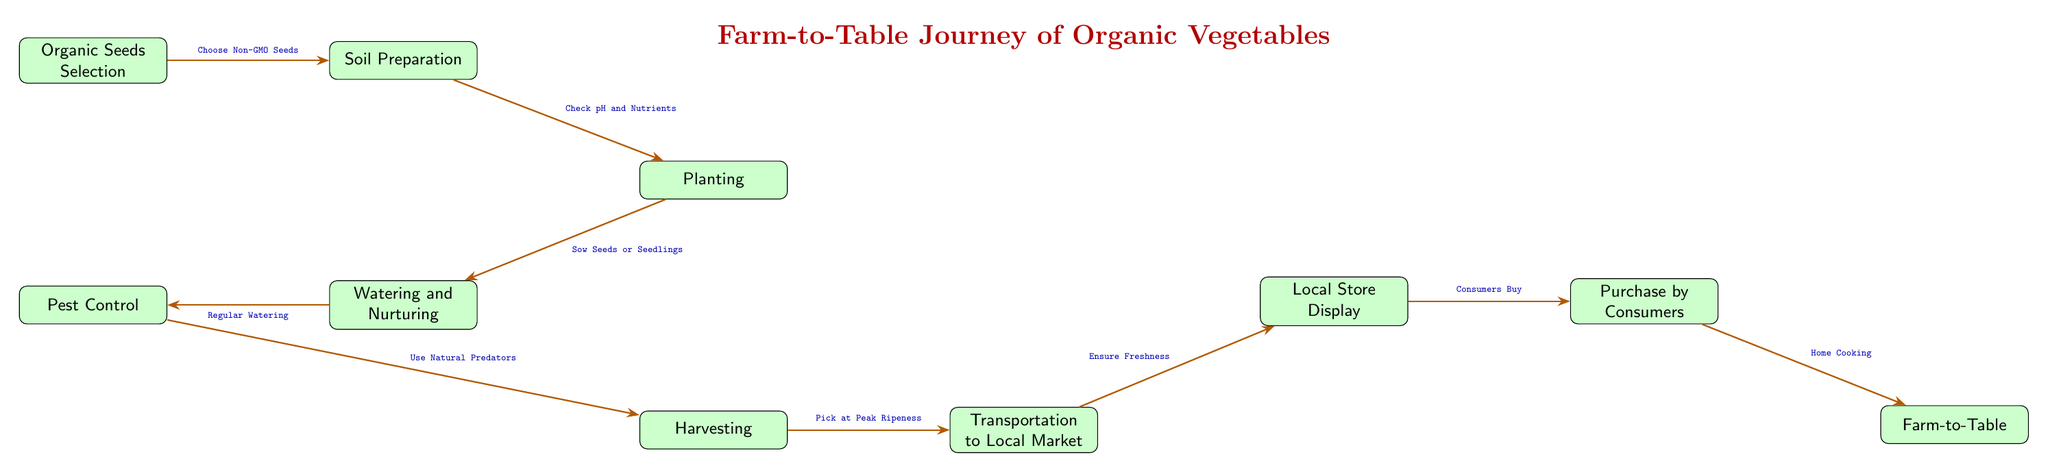What is the first step in the diagram? The first step in the diagram is located at the top, labeled "Organic Seeds Selection". It is the initial action taken in the farm-to-table journey.
Answer: Organic Seeds Selection How many main steps are there in the process? By counting the individual boxes, there are a total of 10 main steps outlined in the diagram, from "Organic Seeds Selection" to "Farm-to-Table".
Answer: 10 What is done immediately after Soil Preparation? The step that follows "Soil Preparation" is "Planting", which is indicated by the arrow connecting the two boxes in the diagram.
Answer: Planting Which step involves dealing with pests? The diagram indicates that "Pest Control" is the step related to managing pests, and it is connected to "Watering and Nurturing" before the harvesting phase.
Answer: Pest Control What is the action taken before harvesting? According to the diagram, the action taken before harvesting is "Watering and Nurturing". It emphasizes the care provided to the plants before they are harvested.
Answer: Watering and Nurturing Explain the connection between Local Store Display and Purchase by Consumers. The connection is represented by an arrow pointing from "Local Store Display" to "Purchase by Consumers". This signifies that after the vegetables are displayed in local stores, consumers purchase them.
Answer: Purchase by Consumers What method is suggested for ensuring freshness before the local market? The diagram indicates that the step for ensuring freshness before reaching the local market is "Ensure Freshness", which is crucial for maintaining the quality of the vegetables post-harvest.
Answer: Ensure Freshness What type of seeds should be chosen initially? The diagram specifies to "Choose Non-GMO Seeds" as the type of seeds for organic farming, highlighting the commitment to sustainable agriculture.
Answer: Non-GMO Seeds What is the last step in the food chain? The final step in the food chain, as shown in the diagram, is "Farm-to-Table", marking the completion of the journey from farm production to consumer kitchens.
Answer: Farm-to-Table 